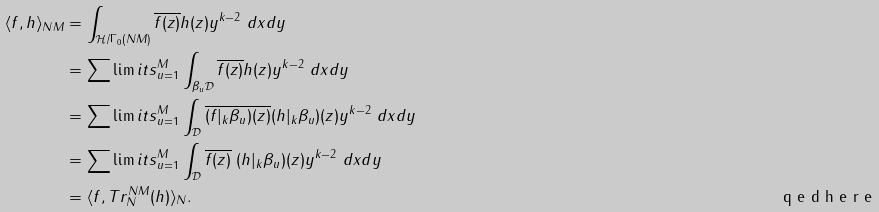<formula> <loc_0><loc_0><loc_500><loc_500>\langle f , h \rangle _ { N M } & = \int _ { \mathcal { H } / \Gamma _ { 0 } ( N M ) } \overline { f ( z ) } h ( z ) y ^ { k - 2 } \ d x d y \\ & = \sum \lim i t s _ { u = 1 } ^ { M } \int _ { \beta _ { u } \mathcal { D } } \overline { f ( z ) } h ( z ) y ^ { k - 2 } \ d x d y \\ & = \sum \lim i t s _ { u = 1 } ^ { M } \int _ { \mathcal { D } } \overline { ( f | _ { k } \beta _ { u } ) ( z ) } ( h | _ { k } \beta _ { u } ) ( z ) y ^ { k - 2 } \ d x d y \\ & = \sum \lim i t s _ { u = 1 } ^ { M } \int _ { \mathcal { D } } \overline { f ( z ) } \ ( h | _ { k } \beta _ { u } ) ( z ) y ^ { k - 2 } \ d x d y \\ & = \langle f , T r _ { N } ^ { N M } ( h ) \rangle _ { N } . \tag* { \ q e d h e r e }</formula> 